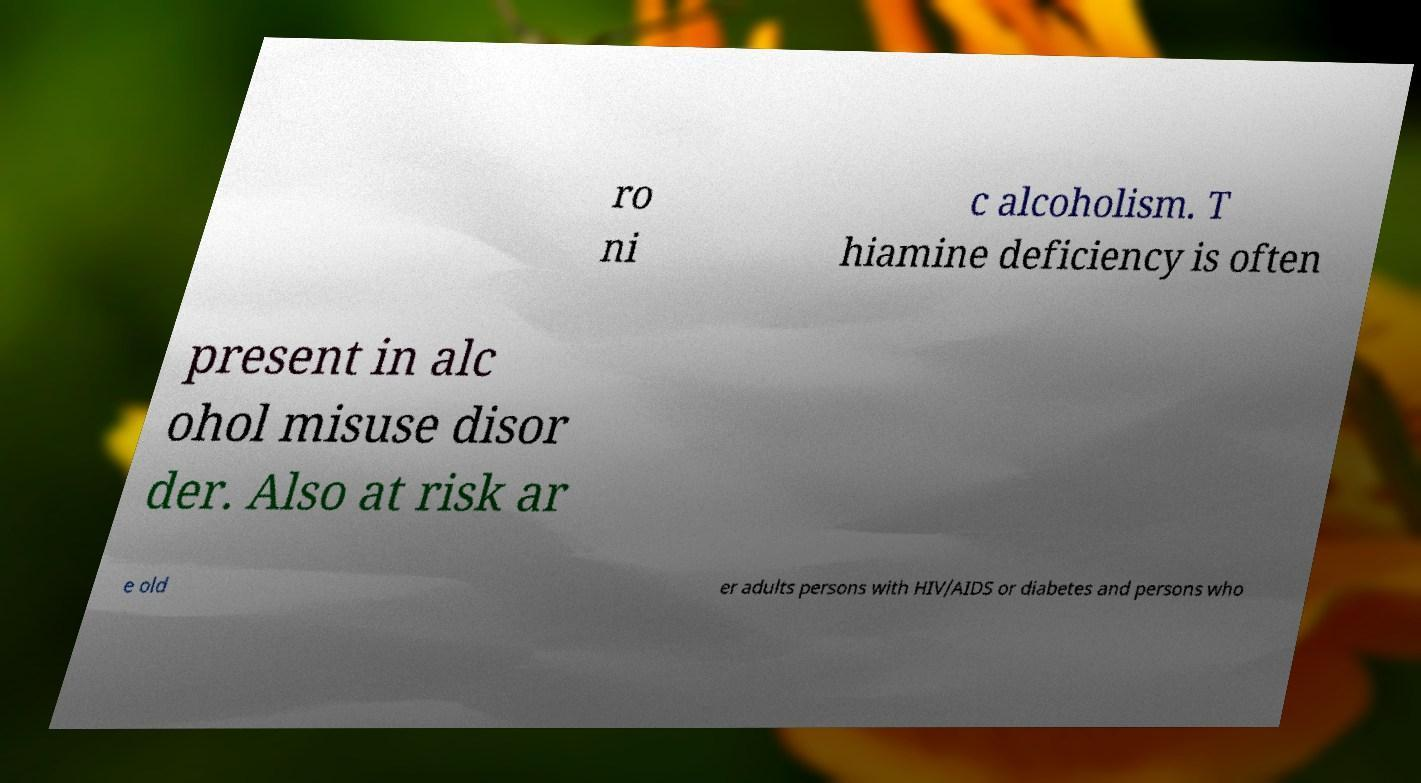There's text embedded in this image that I need extracted. Can you transcribe it verbatim? ro ni c alcoholism. T hiamine deficiency is often present in alc ohol misuse disor der. Also at risk ar e old er adults persons with HIV/AIDS or diabetes and persons who 